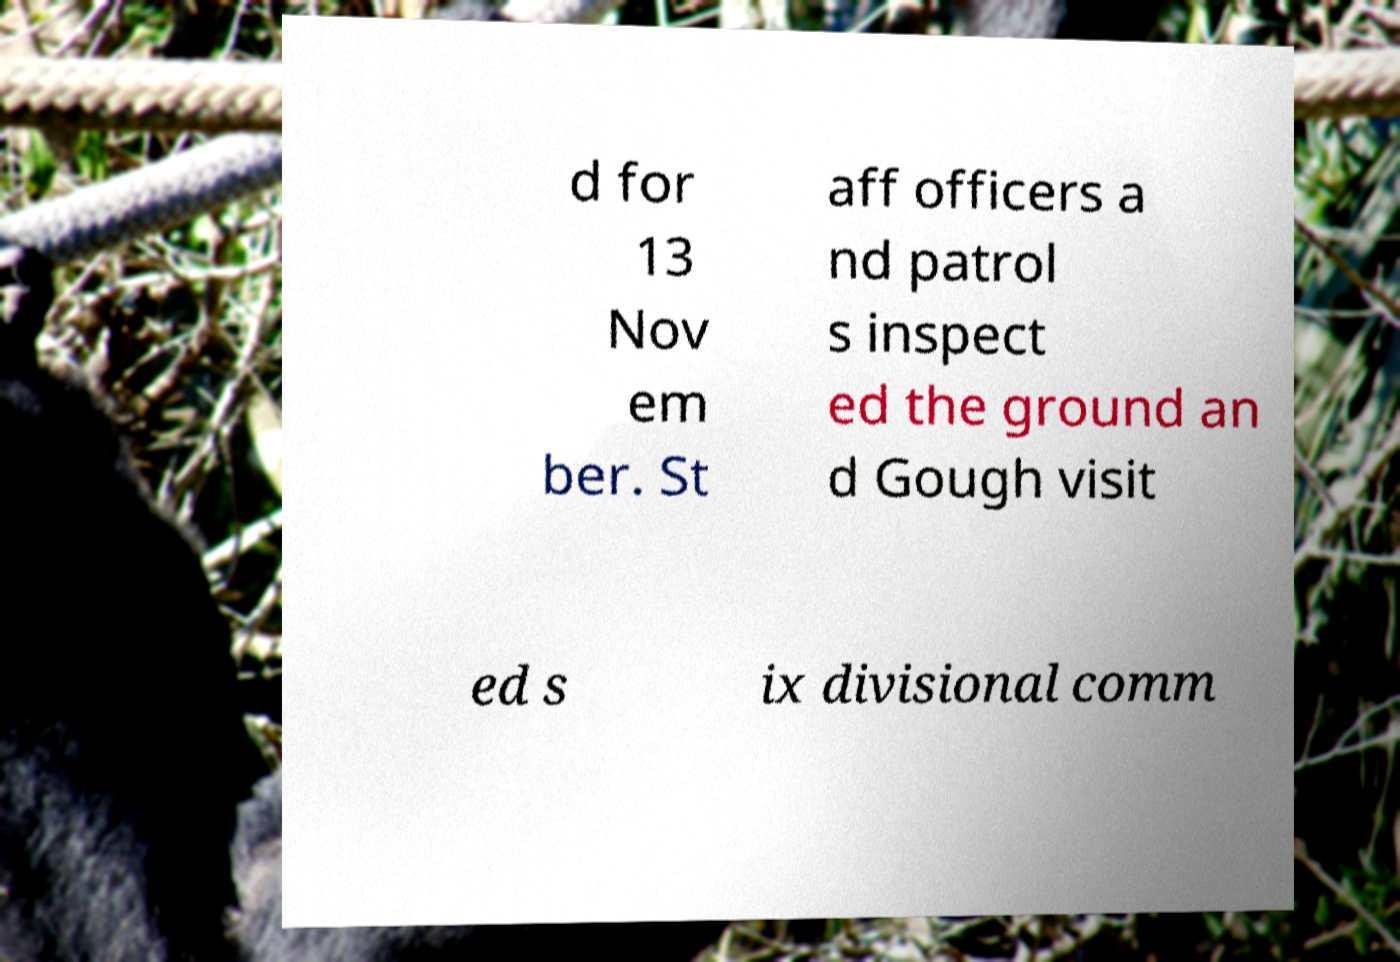Could you assist in decoding the text presented in this image and type it out clearly? d for 13 Nov em ber. St aff officers a nd patrol s inspect ed the ground an d Gough visit ed s ix divisional comm 